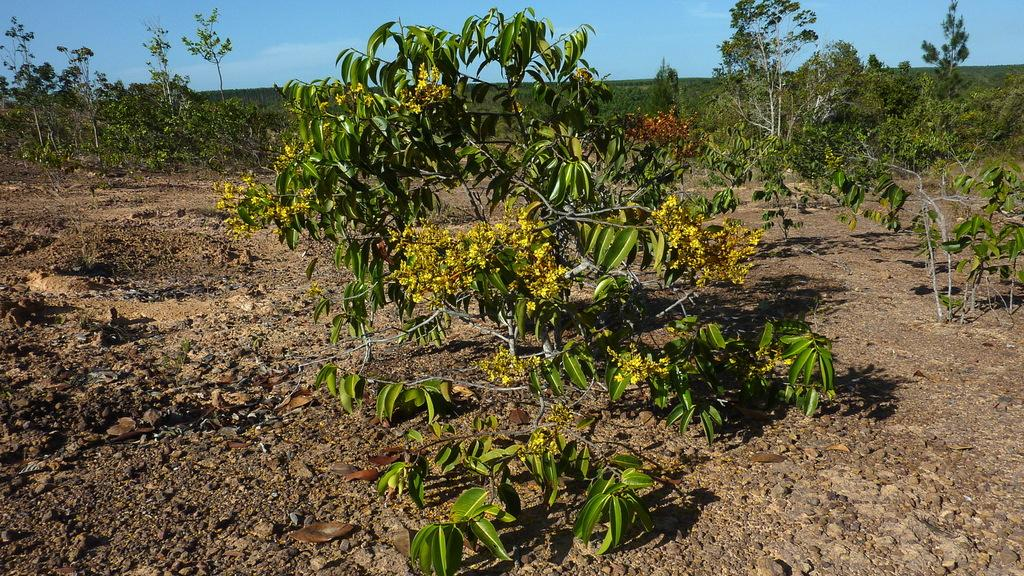What type of vegetation can be seen in the image? There are trees in the image. What color is the sky in the image? The sky is blue in the image. Can you see a coil of wire in the image? There is no coil of wire present in the image. Are there any ants visible on the trees in the image? There are no ants visible in the image. 